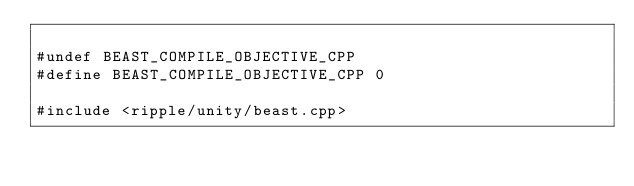Convert code to text. <code><loc_0><loc_0><loc_500><loc_500><_ObjectiveC_>
#undef BEAST_COMPILE_OBJECTIVE_CPP
#define BEAST_COMPILE_OBJECTIVE_CPP 0

#include <ripple/unity/beast.cpp>

</code> 